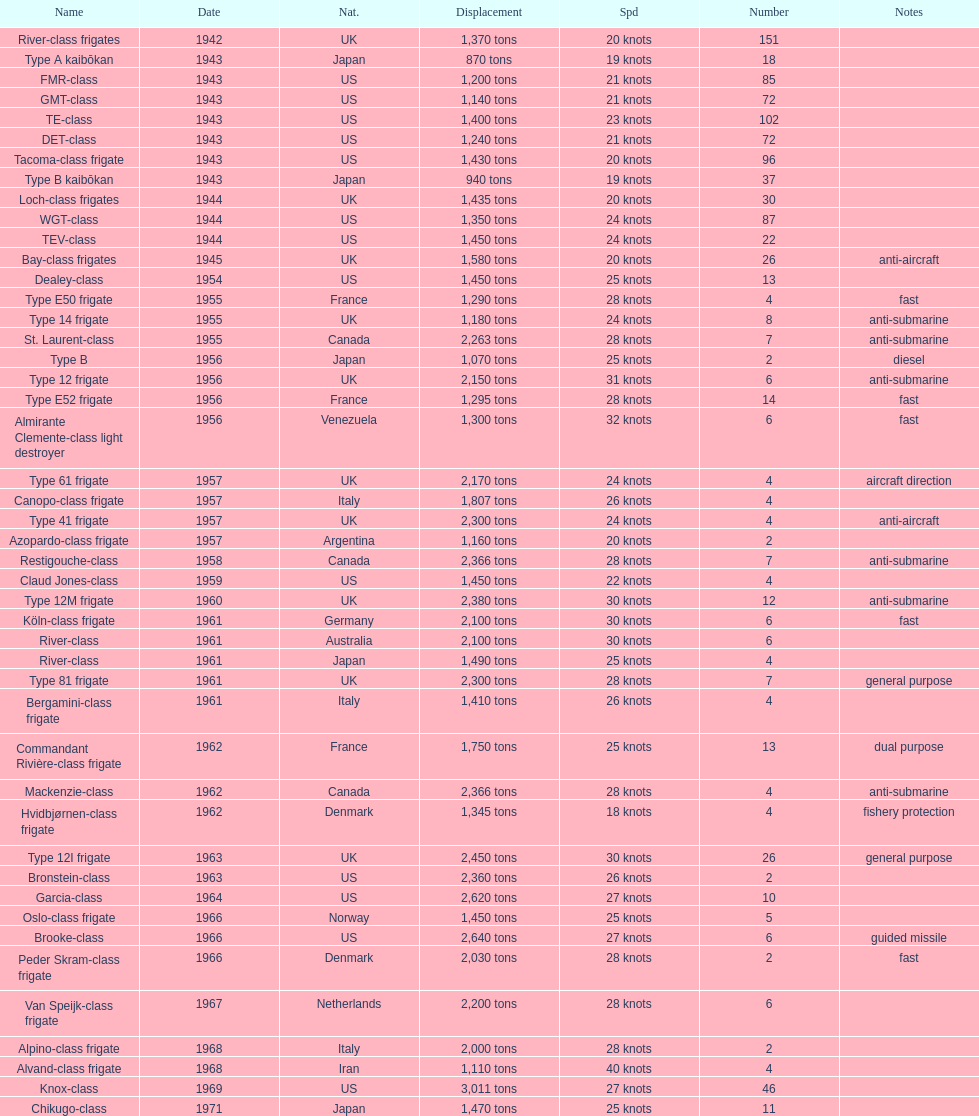How many consecutive escorts were in 1943? 7. Give me the full table as a dictionary. {'header': ['Name', 'Date', 'Nat.', 'Displacement', 'Spd', 'Number', 'Notes'], 'rows': [['River-class frigates', '1942', 'UK', '1,370 tons', '20 knots', '151', ''], ['Type A kaibōkan', '1943', 'Japan', '870 tons', '19 knots', '18', ''], ['FMR-class', '1943', 'US', '1,200 tons', '21 knots', '85', ''], ['GMT-class', '1943', 'US', '1,140 tons', '21 knots', '72', ''], ['TE-class', '1943', 'US', '1,400 tons', '23 knots', '102', ''], ['DET-class', '1943', 'US', '1,240 tons', '21 knots', '72', ''], ['Tacoma-class frigate', '1943', 'US', '1,430 tons', '20 knots', '96', ''], ['Type B kaibōkan', '1943', 'Japan', '940 tons', '19 knots', '37', ''], ['Loch-class frigates', '1944', 'UK', '1,435 tons', '20 knots', '30', ''], ['WGT-class', '1944', 'US', '1,350 tons', '24 knots', '87', ''], ['TEV-class', '1944', 'US', '1,450 tons', '24 knots', '22', ''], ['Bay-class frigates', '1945', 'UK', '1,580 tons', '20 knots', '26', 'anti-aircraft'], ['Dealey-class', '1954', 'US', '1,450 tons', '25 knots', '13', ''], ['Type E50 frigate', '1955', 'France', '1,290 tons', '28 knots', '4', 'fast'], ['Type 14 frigate', '1955', 'UK', '1,180 tons', '24 knots', '8', 'anti-submarine'], ['St. Laurent-class', '1955', 'Canada', '2,263 tons', '28 knots', '7', 'anti-submarine'], ['Type B', '1956', 'Japan', '1,070 tons', '25 knots', '2', 'diesel'], ['Type 12 frigate', '1956', 'UK', '2,150 tons', '31 knots', '6', 'anti-submarine'], ['Type E52 frigate', '1956', 'France', '1,295 tons', '28 knots', '14', 'fast'], ['Almirante Clemente-class light destroyer', '1956', 'Venezuela', '1,300 tons', '32 knots', '6', 'fast'], ['Type 61 frigate', '1957', 'UK', '2,170 tons', '24 knots', '4', 'aircraft direction'], ['Canopo-class frigate', '1957', 'Italy', '1,807 tons', '26 knots', '4', ''], ['Type 41 frigate', '1957', 'UK', '2,300 tons', '24 knots', '4', 'anti-aircraft'], ['Azopardo-class frigate', '1957', 'Argentina', '1,160 tons', '20 knots', '2', ''], ['Restigouche-class', '1958', 'Canada', '2,366 tons', '28 knots', '7', 'anti-submarine'], ['Claud Jones-class', '1959', 'US', '1,450 tons', '22 knots', '4', ''], ['Type 12M frigate', '1960', 'UK', '2,380 tons', '30 knots', '12', 'anti-submarine'], ['Köln-class frigate', '1961', 'Germany', '2,100 tons', '30 knots', '6', 'fast'], ['River-class', '1961', 'Australia', '2,100 tons', '30 knots', '6', ''], ['River-class', '1961', 'Japan', '1,490 tons', '25 knots', '4', ''], ['Type 81 frigate', '1961', 'UK', '2,300 tons', '28 knots', '7', 'general purpose'], ['Bergamini-class frigate', '1961', 'Italy', '1,410 tons', '26 knots', '4', ''], ['Commandant Rivière-class frigate', '1962', 'France', '1,750 tons', '25 knots', '13', 'dual purpose'], ['Mackenzie-class', '1962', 'Canada', '2,366 tons', '28 knots', '4', 'anti-submarine'], ['Hvidbjørnen-class frigate', '1962', 'Denmark', '1,345 tons', '18 knots', '4', 'fishery protection'], ['Type 12I frigate', '1963', 'UK', '2,450 tons', '30 knots', '26', 'general purpose'], ['Bronstein-class', '1963', 'US', '2,360 tons', '26 knots', '2', ''], ['Garcia-class', '1964', 'US', '2,620 tons', '27 knots', '10', ''], ['Oslo-class frigate', '1966', 'Norway', '1,450 tons', '25 knots', '5', ''], ['Brooke-class', '1966', 'US', '2,640 tons', '27 knots', '6', 'guided missile'], ['Peder Skram-class frigate', '1966', 'Denmark', '2,030 tons', '28 knots', '2', 'fast'], ['Van Speijk-class frigate', '1967', 'Netherlands', '2,200 tons', '28 knots', '6', ''], ['Alpino-class frigate', '1968', 'Italy', '2,000 tons', '28 knots', '2', ''], ['Alvand-class frigate', '1968', 'Iran', '1,110 tons', '40 knots', '4', ''], ['Knox-class', '1969', 'US', '3,011 tons', '27 knots', '46', ''], ['Chikugo-class', '1971', 'Japan', '1,470 tons', '25 knots', '11', '']]} 